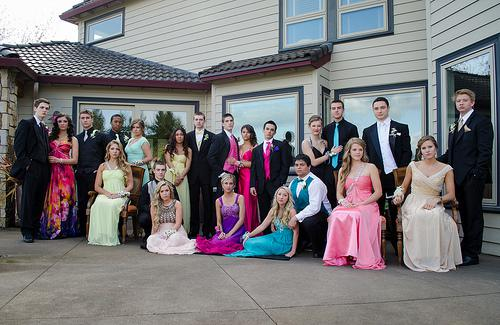Question: what people are doing?
Choices:
A. Ready for photo.
B. Talking.
C. Laughing.
D. Posing.
Answer with the letter. Answer: A Question: where is the image taken?
Choices:
A. In the park.
B. Near to house.
C. On the beach.
D. On the highway.
Answer with the letter. Answer: B Question: what are all the man dress color?
Choices:
A. Black.
B. Navy blue.
C. Grey.
D. Brown.
Answer with the letter. Answer: A Question: who is in the image?
Choices:
A. Baseball players.
B. Men,women,kids.
C. School kids.
D. Soccer fans.
Answer with the letter. Answer: B 